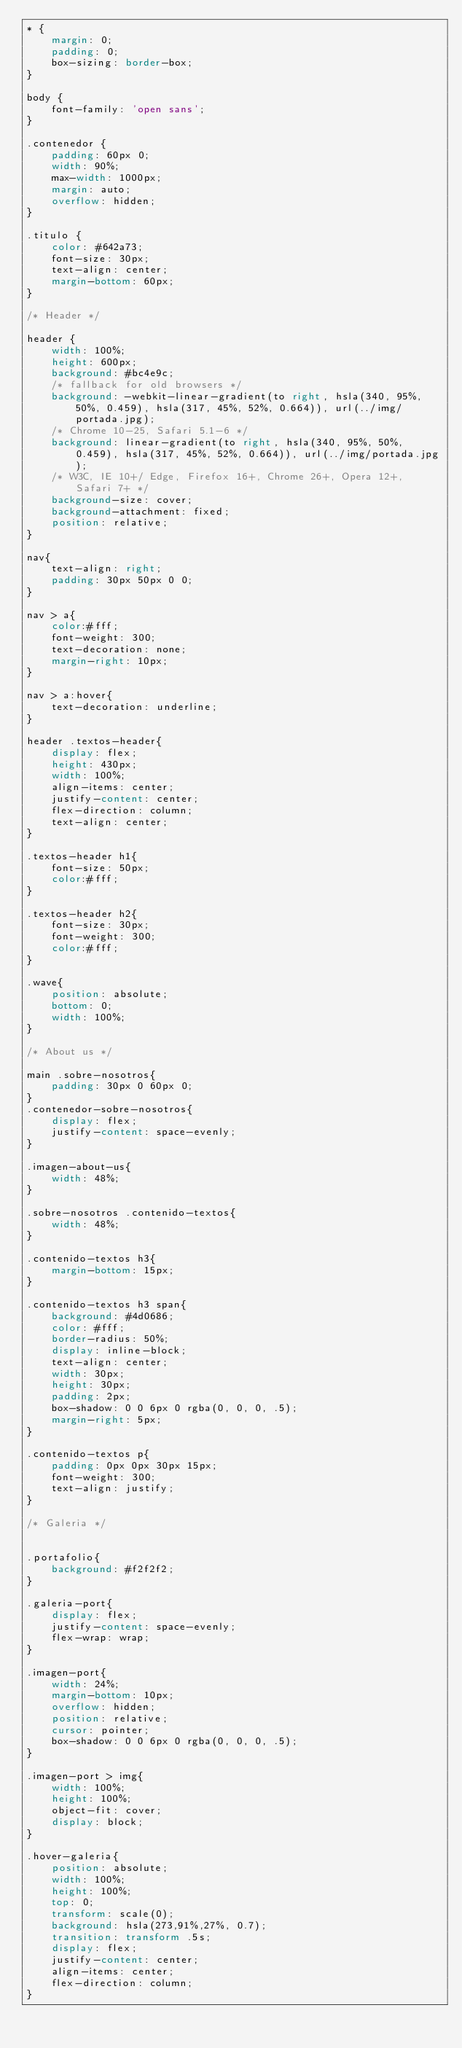<code> <loc_0><loc_0><loc_500><loc_500><_CSS_>* {
    margin: 0;
    padding: 0;
    box-sizing: border-box;
}

body {
    font-family: 'open sans';
}

.contenedor {
    padding: 60px 0;
    width: 90%;
    max-width: 1000px;
    margin: auto;
    overflow: hidden;
}

.titulo {
    color: #642a73;
    font-size: 30px;
    text-align: center;
    margin-bottom: 60px;
}

/* Header */

header {
    width: 100%;
    height: 600px;
    background: #bc4e9c;
    /* fallback for old browsers */
    background: -webkit-linear-gradient(to right, hsla(340, 95%, 50%, 0.459), hsla(317, 45%, 52%, 0.664)), url(../img/portada.jpg);
    /* Chrome 10-25, Safari 5.1-6 */
    background: linear-gradient(to right, hsla(340, 95%, 50%, 0.459), hsla(317, 45%, 52%, 0.664)), url(../img/portada.jpg);
    /* W3C, IE 10+/ Edge, Firefox 16+, Chrome 26+, Opera 12+, Safari 7+ */
    background-size: cover;
    background-attachment: fixed;
    position: relative;
}

nav{
    text-align: right;
    padding: 30px 50px 0 0;
}

nav > a{
    color:#fff;
    font-weight: 300;
    text-decoration: none;
    margin-right: 10px;
}

nav > a:hover{
    text-decoration: underline;
}

header .textos-header{
    display: flex;
    height: 430px;
    width: 100%;
    align-items: center;
    justify-content: center;
    flex-direction: column;
    text-align: center;
}

.textos-header h1{
    font-size: 50px;
    color:#fff;
}

.textos-header h2{
    font-size: 30px;
    font-weight: 300;
    color:#fff;
}

.wave{
    position: absolute;
    bottom: 0;
    width: 100%;
}

/* About us */

main .sobre-nosotros{
    padding: 30px 0 60px 0;
}
.contenedor-sobre-nosotros{
    display: flex;
    justify-content: space-evenly;
}

.imagen-about-us{
    width: 48%;
}

.sobre-nosotros .contenido-textos{
    width: 48%;
}

.contenido-textos h3{
    margin-bottom: 15px;
}

.contenido-textos h3 span{
    background: #4d0686;
    color: #fff;
    border-radius: 50%;
    display: inline-block;
    text-align: center;
    width: 30px;
    height: 30px;
    padding: 2px;
    box-shadow: 0 0 6px 0 rgba(0, 0, 0, .5);
    margin-right: 5px;
}

.contenido-textos p{
    padding: 0px 0px 30px 15px;
    font-weight: 300;
    text-align: justify;
}

/* Galeria */


.portafolio{
    background: #f2f2f2;
}

.galeria-port{
    display: flex;
    justify-content: space-evenly;
    flex-wrap: wrap;
}

.imagen-port{
    width: 24%;
    margin-bottom: 10px;
    overflow: hidden;
    position: relative;
    cursor: pointer;
    box-shadow: 0 0 6px 0 rgba(0, 0, 0, .5);
}

.imagen-port > img{
    width: 100%;
    height: 100%;
    object-fit: cover;
    display: block;
}

.hover-galeria{
    position: absolute;
    width: 100%;
    height: 100%;
    top: 0;
    transform: scale(0);
    background: hsla(273,91%,27%, 0.7);
    transition: transform .5s;
    display: flex;
    justify-content: center;
    align-items: center;
    flex-direction: column;
}
</code> 